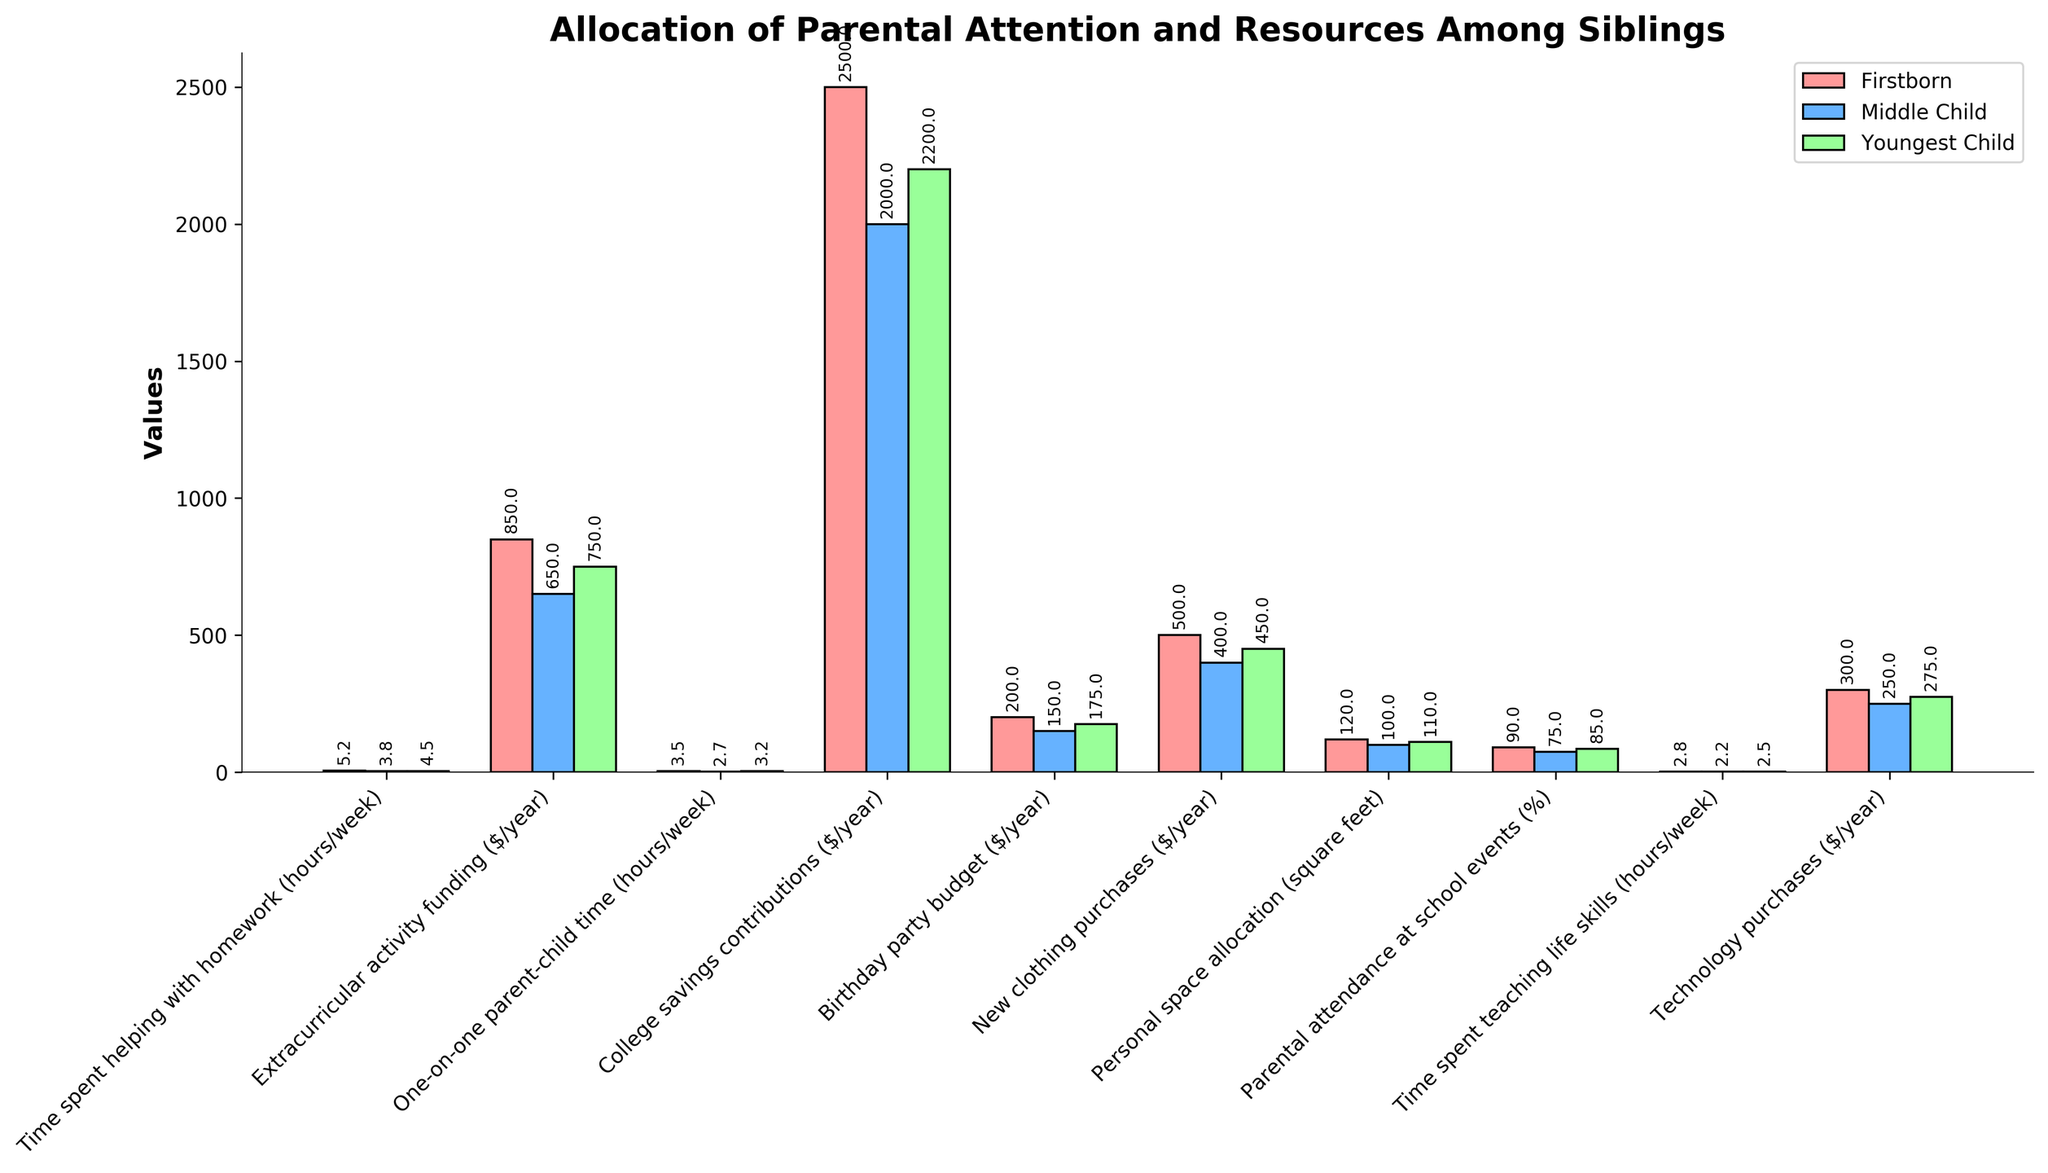Does the firstborn receive more one-on-one parent-child time than the youngest child? Compare the bar heights for "One-on-one parent-child time (hours/week)" between the firstborn and the youngest child. The bar for the firstborn is higher than the bar for the youngest child.
Answer: Yes Which sibling receives the least amount of parental attendance at school events? Compare the bar heights for "Parental attendance at school events (%)" among the three siblings. The middle child has the shortest bar.
Answer: Middle Child What is the total amount of weekly time spent helping with homework for all siblings combined? Sum the values for "Time spent helping with homework (hours/week)" for all three siblings: 5.2 (Firstborn) + 3.8 (Middle Child) + 4.5 (Youngest Child) = 13.5.
Answer: 13.5 Out of the siblings, who gets the most new clothing purchases in a year? Compare the bar heights for "New clothing purchases ($/year)" among the three siblings. The firstborn has the tallest bar.
Answer: Firstborn What is the difference in technology purchases per year between the middle child and the youngest child? Subtract the value for "Technology purchases ($/year)" of the middle child from that of the youngest child: 275 (Youngest Child) - 250 (Middle Child) = 25.
Answer: 25 Does the middle child get less extracurricular activity funding compared to the youngest child? Compare the bar heights for "Extracurricular activity funding ($/year)" of the middle child and the youngest child. The middle child's bar is shorter than the youngest child's bar.
Answer: Yes Which category shows the greatest difference in parental resource allocation between the firstborn and middle child? Compare the differences in heights for each category between the firstborn and the middle child, and identify the largest difference. "College savings contributions ($/year)" shows the greatest difference with 2500 (Firstborn) - 2000 (Middle Child) = 500.
Answer: College savings contributions How much more personal space does the firstborn have compared to the middle child? Subtract the value for "Personal space allocation (square feet)" of the middle child from that of the firstborn: 120 (Firstborn) - 100 (Middle Child) = 20.
Answer: 20 What is the average birthday party budget for all the siblings? Calculate the average of the values for "Birthday party budget ($/year)": (200 + 150 + 175) / 3 = 525 / 3 = 175.
Answer: 175 Who receives the least attention in terms of weekly time spent teaching life skills? Compare the bar heights for "Time spent teaching life skills (hours/week)" among the three siblings. The middle child has the shortest bar.
Answer: Middle Child 